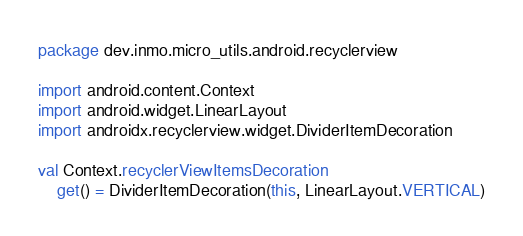Convert code to text. <code><loc_0><loc_0><loc_500><loc_500><_Kotlin_>package dev.inmo.micro_utils.android.recyclerview

import android.content.Context
import android.widget.LinearLayout
import androidx.recyclerview.widget.DividerItemDecoration

val Context.recyclerViewItemsDecoration
    get() = DividerItemDecoration(this, LinearLayout.VERTICAL)

</code> 